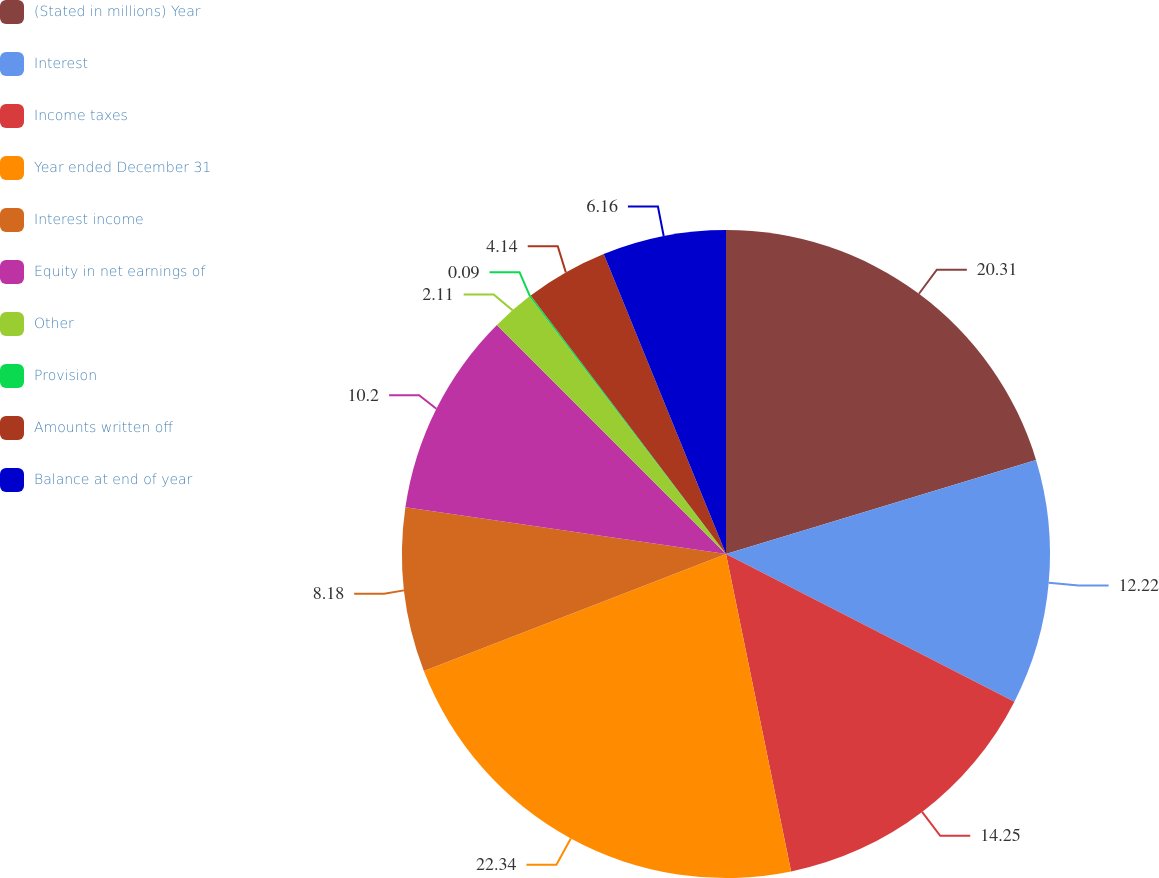Convert chart. <chart><loc_0><loc_0><loc_500><loc_500><pie_chart><fcel>(Stated in millions) Year<fcel>Interest<fcel>Income taxes<fcel>Year ended December 31<fcel>Interest income<fcel>Equity in net earnings of<fcel>Other<fcel>Provision<fcel>Amounts written off<fcel>Balance at end of year<nl><fcel>20.31%<fcel>12.22%<fcel>14.25%<fcel>22.34%<fcel>8.18%<fcel>10.2%<fcel>2.11%<fcel>0.09%<fcel>4.14%<fcel>6.16%<nl></chart> 